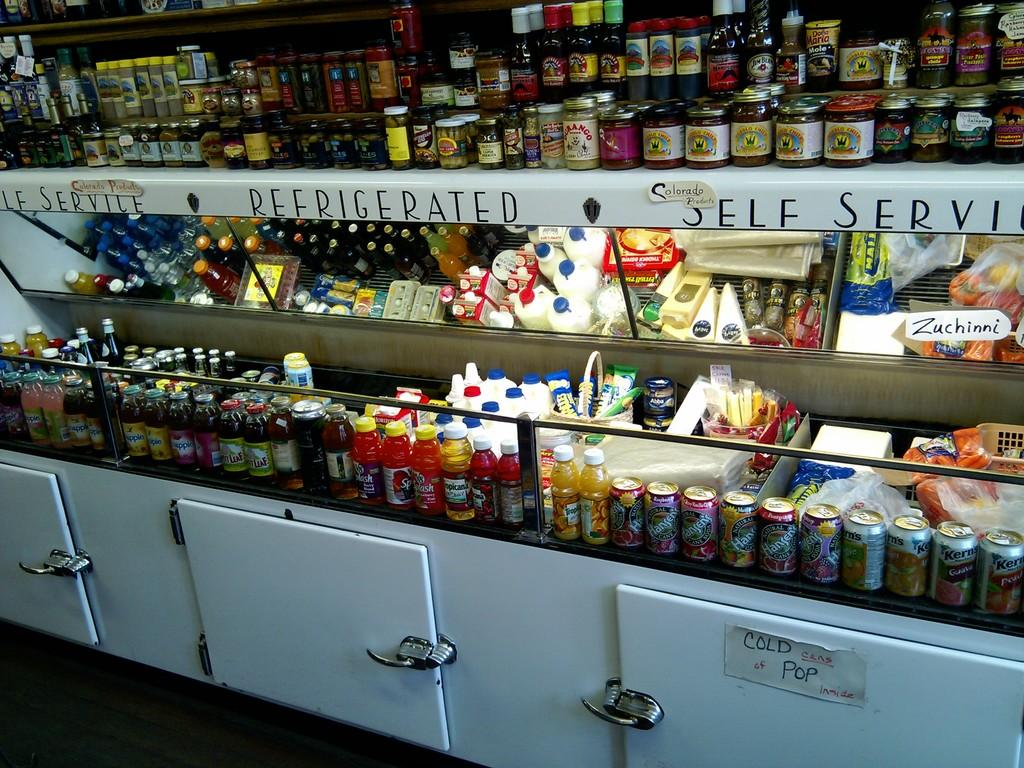Provide a one-sentence caption for the provided image. Refrigerated self service section in a grocery store. 